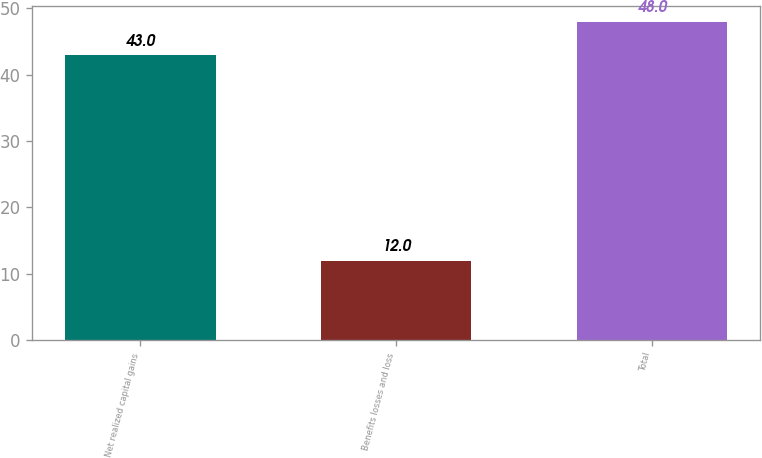<chart> <loc_0><loc_0><loc_500><loc_500><bar_chart><fcel>Net realized capital gains<fcel>Benefits losses and loss<fcel>Total<nl><fcel>43<fcel>12<fcel>48<nl></chart> 